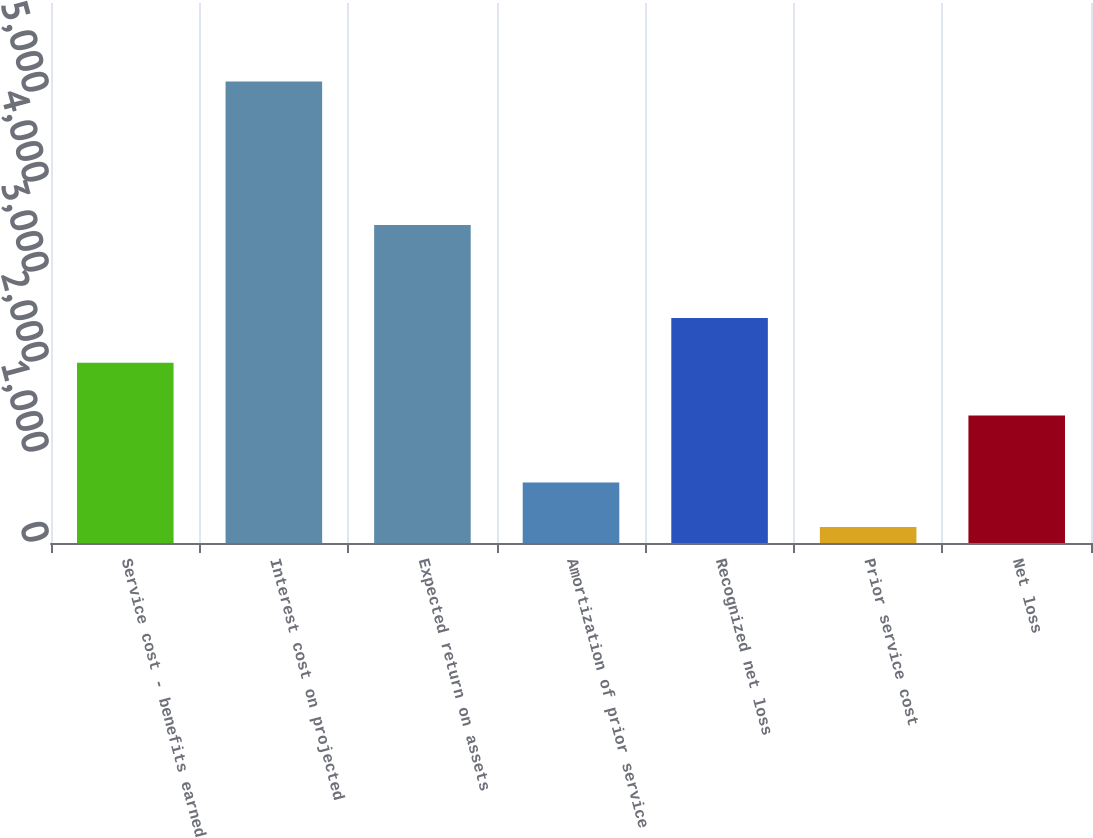Convert chart to OTSL. <chart><loc_0><loc_0><loc_500><loc_500><bar_chart><fcel>Service cost - benefits earned<fcel>Interest cost on projected<fcel>Expected return on assets<fcel>Amortization of prior service<fcel>Recognized net loss<fcel>Prior service cost<fcel>Net loss<nl><fcel>2004<fcel>5127<fcel>3534<fcel>672.9<fcel>2498.9<fcel>178<fcel>1417<nl></chart> 